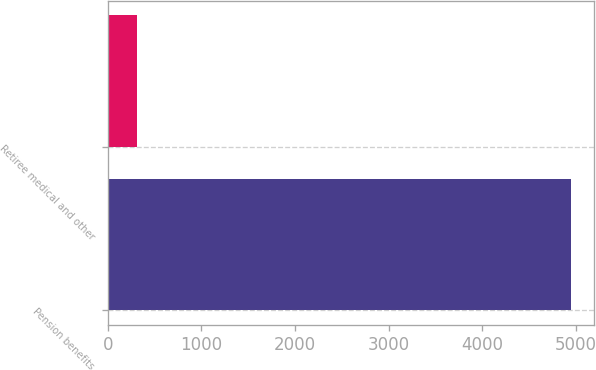<chart> <loc_0><loc_0><loc_500><loc_500><bar_chart><fcel>Pension benefits<fcel>Retiree medical and other<nl><fcel>4951<fcel>314<nl></chart> 